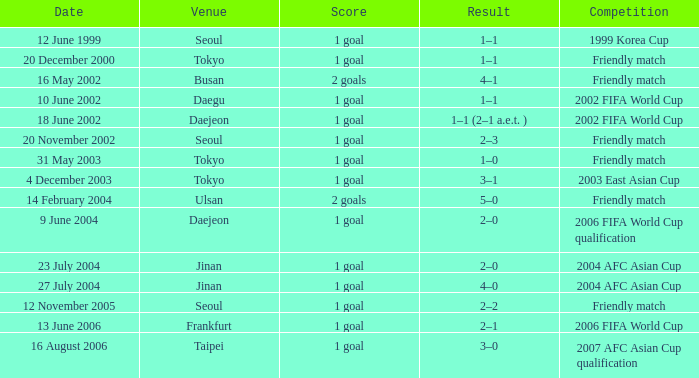What is the competition that occured on 27 July 2004? 2004 AFC Asian Cup. 